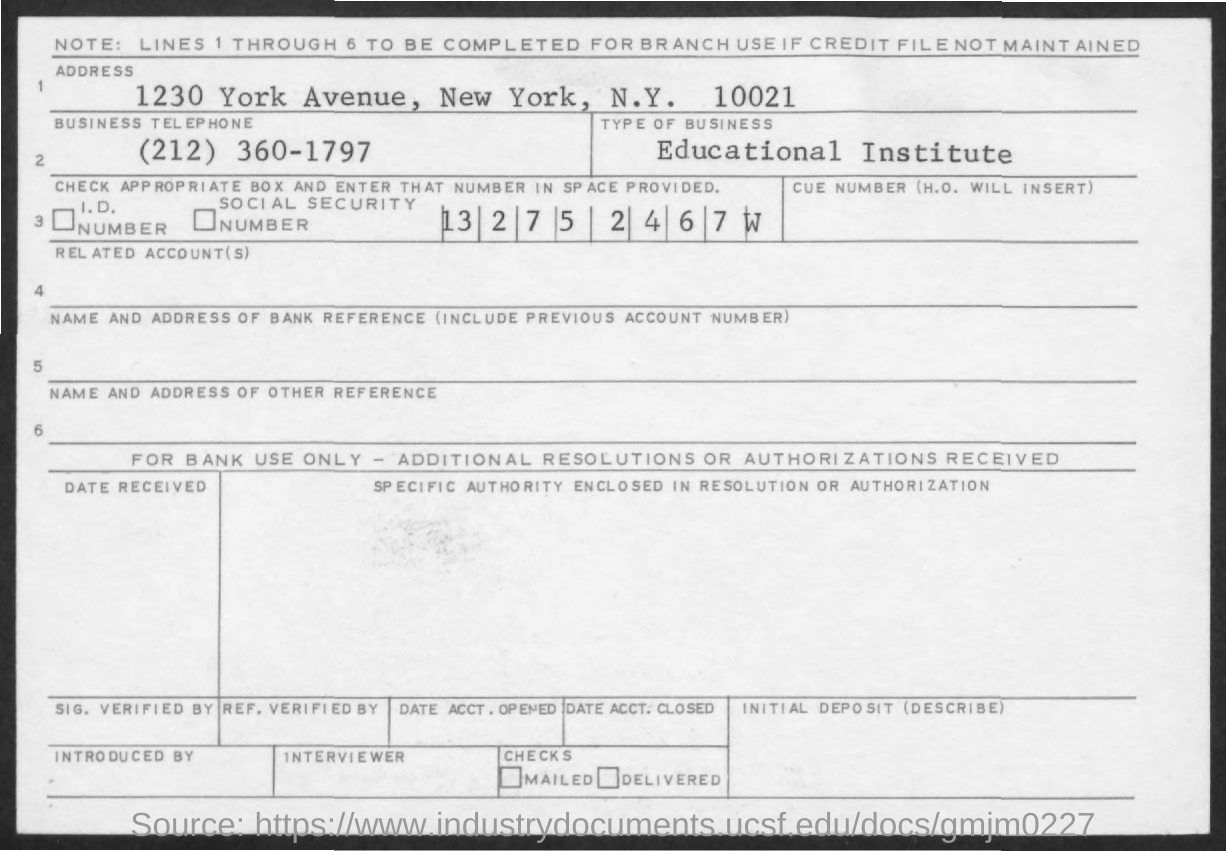What is the type of business mentioned ?
Offer a very short reply. Educational Institute. What is the address mentioned ?
Provide a short and direct response. 1230  york avenue, new york , N.Y. 10021. What is the business telephone no. mentioned ?
Provide a short and direct response. (212) 360-1797. 